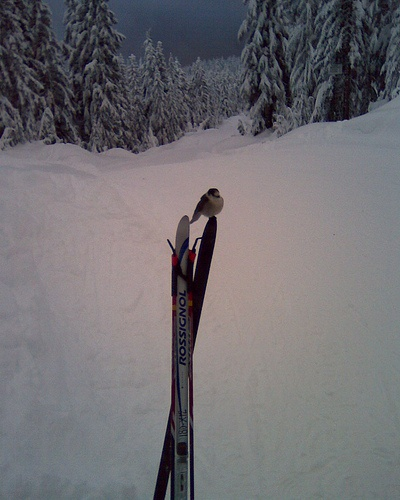Describe the objects in this image and their specific colors. I can see skis in black, gray, and maroon tones and bird in black, gray, and maroon tones in this image. 